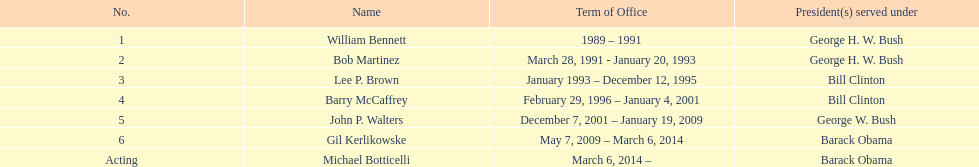Who was the succeeding appointed director post lee p. brown? Barry McCaffrey. 